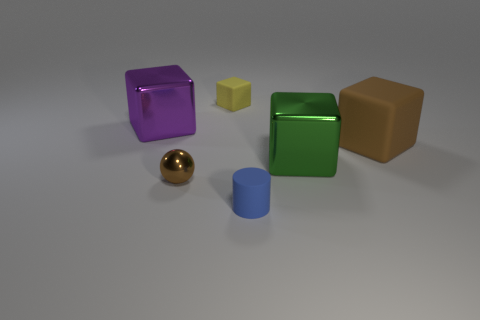What number of matte objects are blue things or tiny cubes?
Your response must be concise. 2. There is another small thing that is the same shape as the green object; what color is it?
Give a very brief answer. Yellow. How many shiny objects have the same color as the large rubber cube?
Provide a succinct answer. 1. There is a small rubber thing that is behind the big matte thing; is there a big metal object that is to the right of it?
Offer a very short reply. Yes. How many metallic things are in front of the green metal thing and behind the tiny brown shiny ball?
Offer a very short reply. 0. What number of tiny brown spheres have the same material as the big green object?
Offer a terse response. 1. There is a purple thing on the left side of the brown thing that is to the left of the big green thing; what size is it?
Provide a succinct answer. Large. Is there a big blue thing of the same shape as the large green thing?
Offer a very short reply. No. Is the size of the metallic thing on the right side of the small yellow rubber cube the same as the brown thing that is left of the yellow object?
Offer a terse response. No. Are there fewer blue cylinders that are to the right of the green metallic object than yellow things that are left of the small brown metal thing?
Give a very brief answer. No. 